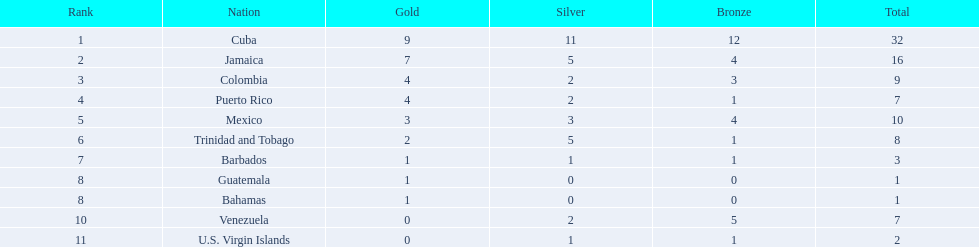In which country have they achieved 4 or more gold medals? Cuba, Jamaica, Colombia, Puerto Rico. From these countries, which one has the fewest bronze medals? Puerto Rico. 